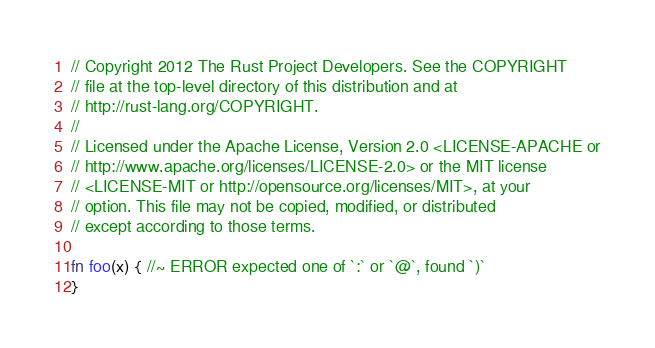Convert code to text. <code><loc_0><loc_0><loc_500><loc_500><_Rust_>// Copyright 2012 The Rust Project Developers. See the COPYRIGHT
// file at the top-level directory of this distribution and at
// http://rust-lang.org/COPYRIGHT.
//
// Licensed under the Apache License, Version 2.0 <LICENSE-APACHE or
// http://www.apache.org/licenses/LICENSE-2.0> or the MIT license
// <LICENSE-MIT or http://opensource.org/licenses/MIT>, at your
// option. This file may not be copied, modified, or distributed
// except according to those terms.

fn foo(x) { //~ ERROR expected one of `:` or `@`, found `)`
}
</code> 